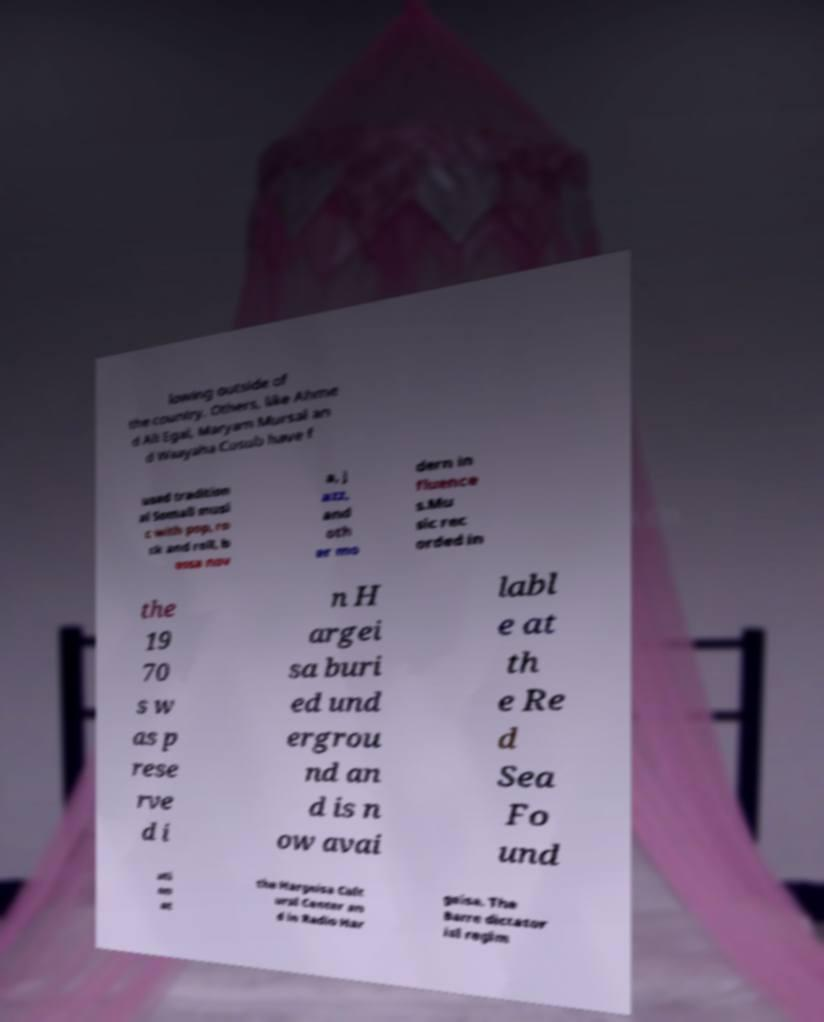I need the written content from this picture converted into text. Can you do that? lowing outside of the country. Others, like Ahme d Ali Egal, Maryam Mursal an d Waayaha Cusub have f used tradition al Somali musi c with pop, ro ck and roll, b ossa nov a, j azz, and oth er mo dern in fluence s.Mu sic rec orded in the 19 70 s w as p rese rve d i n H argei sa buri ed und ergrou nd an d is n ow avai labl e at th e Re d Sea Fo und ati on at the Hargeisa Cult ural Center an d in Radio Har geisa. The Barre dictator ial regim 